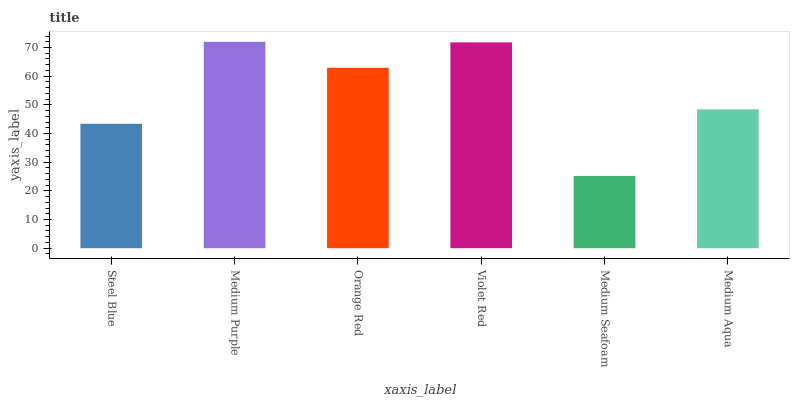Is Medium Seafoam the minimum?
Answer yes or no. Yes. Is Medium Purple the maximum?
Answer yes or no. Yes. Is Orange Red the minimum?
Answer yes or no. No. Is Orange Red the maximum?
Answer yes or no. No. Is Medium Purple greater than Orange Red?
Answer yes or no. Yes. Is Orange Red less than Medium Purple?
Answer yes or no. Yes. Is Orange Red greater than Medium Purple?
Answer yes or no. No. Is Medium Purple less than Orange Red?
Answer yes or no. No. Is Orange Red the high median?
Answer yes or no. Yes. Is Medium Aqua the low median?
Answer yes or no. Yes. Is Medium Purple the high median?
Answer yes or no. No. Is Medium Seafoam the low median?
Answer yes or no. No. 